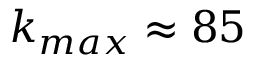<formula> <loc_0><loc_0><loc_500><loc_500>k _ { \max } \approx 8 5</formula> 